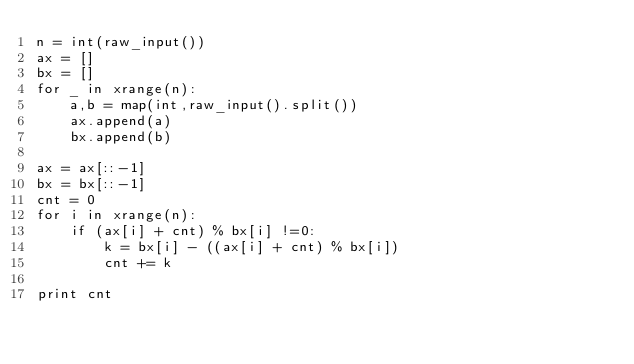<code> <loc_0><loc_0><loc_500><loc_500><_Python_>n = int(raw_input())
ax = []
bx = []
for _ in xrange(n):
    a,b = map(int,raw_input().split())
    ax.append(a)
    bx.append(b)

ax = ax[::-1]
bx = bx[::-1]
cnt = 0
for i in xrange(n):
    if (ax[i] + cnt) % bx[i] !=0:
        k = bx[i] - ((ax[i] + cnt) % bx[i])
        cnt += k

print cnt
</code> 